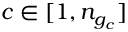Convert formula to latex. <formula><loc_0><loc_0><loc_500><loc_500>c \in [ 1 , n _ { g _ { c } } ]</formula> 